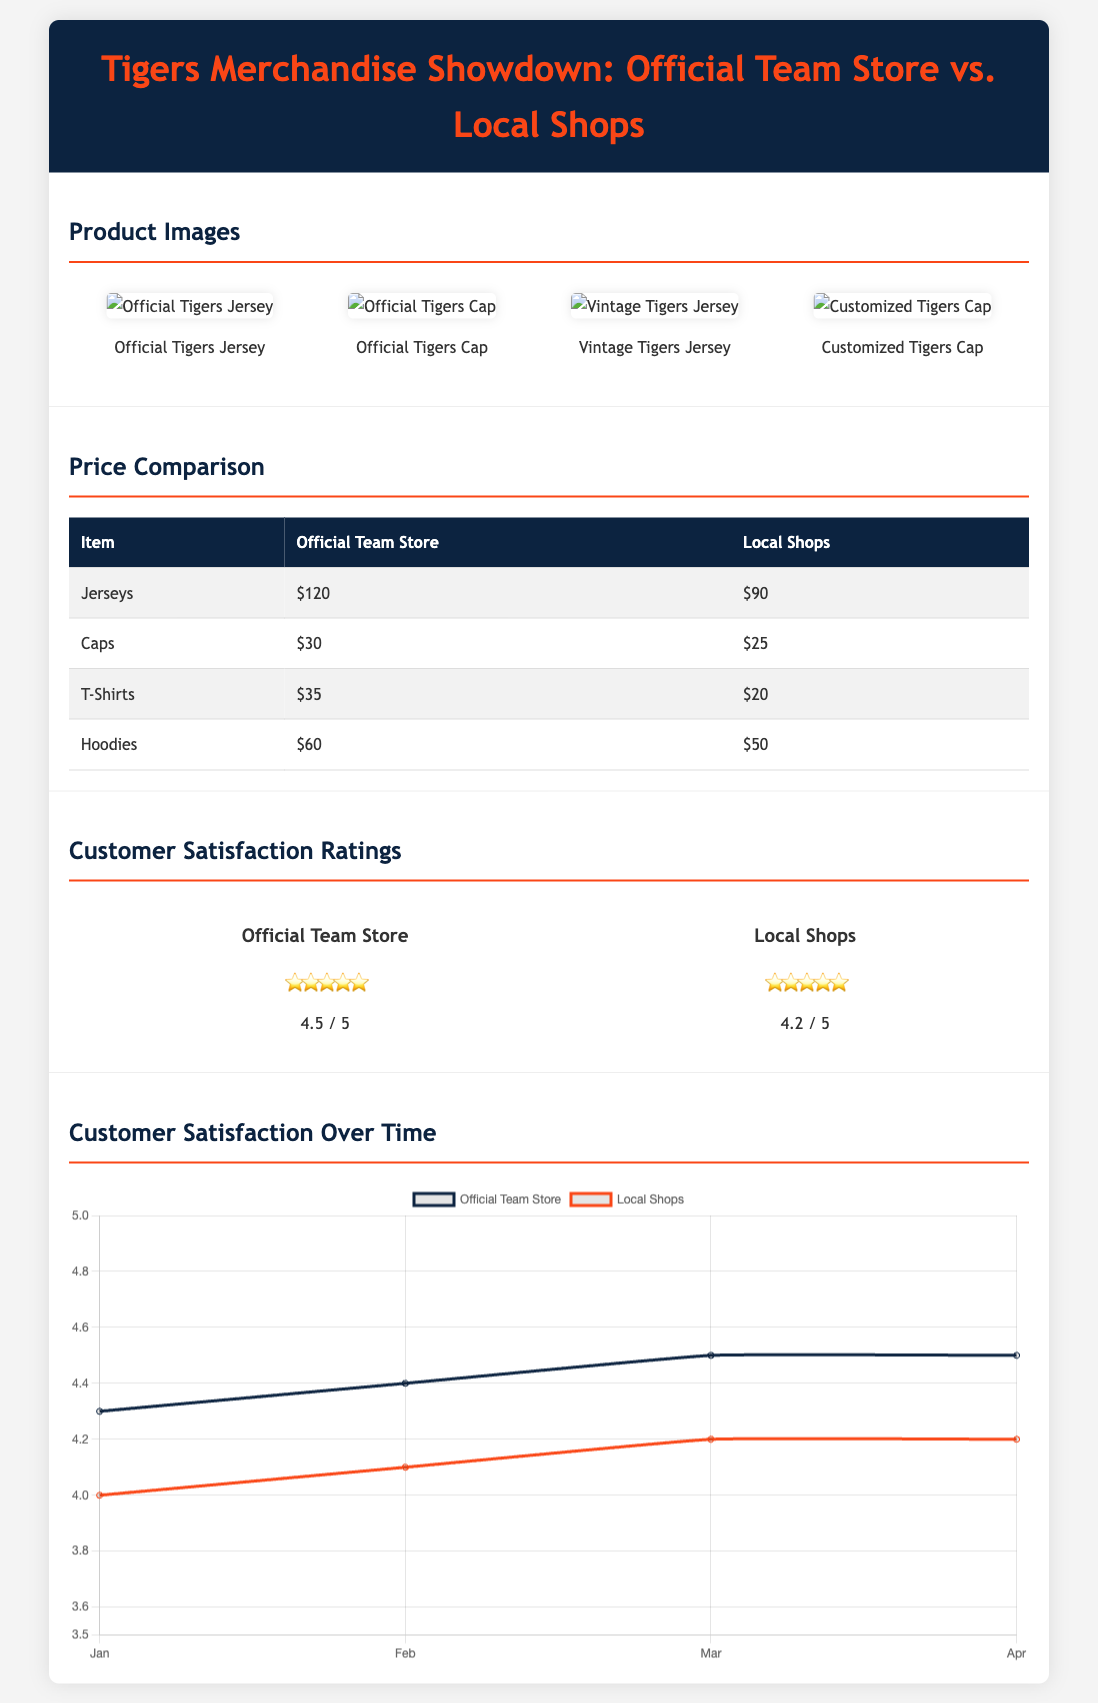What is the price of the official Tigers jersey? The price of the official Tigers jersey is listed in the Price Comparison table under the Official Team Store section.
Answer: $120 Which item is cheaper at local shops than at the official team store? The Price Comparison table shows the price for Jerseys, Caps, T-Shirts, and Hoodies for both stores, highlighting which items are cheaper at local shops.
Answer: T-Shirts What customer satisfaction rating did the Official Team Store receive? The customer satisfaction ratings section displays the ratings for both the Official Team Store and Local Shops.
Answer: 4.5 / 5 Which shop has a higher customer satisfaction rating? By comparing the ratings provided for both shops, we can see which one is rated higher in customer satisfaction.
Answer: Official Team Store What month showed the highest rating for Local Shops? Reviewing the Customer Satisfaction Over Time graph allows us to identify the month with the highest rating for Local Shops.
Answer: March 